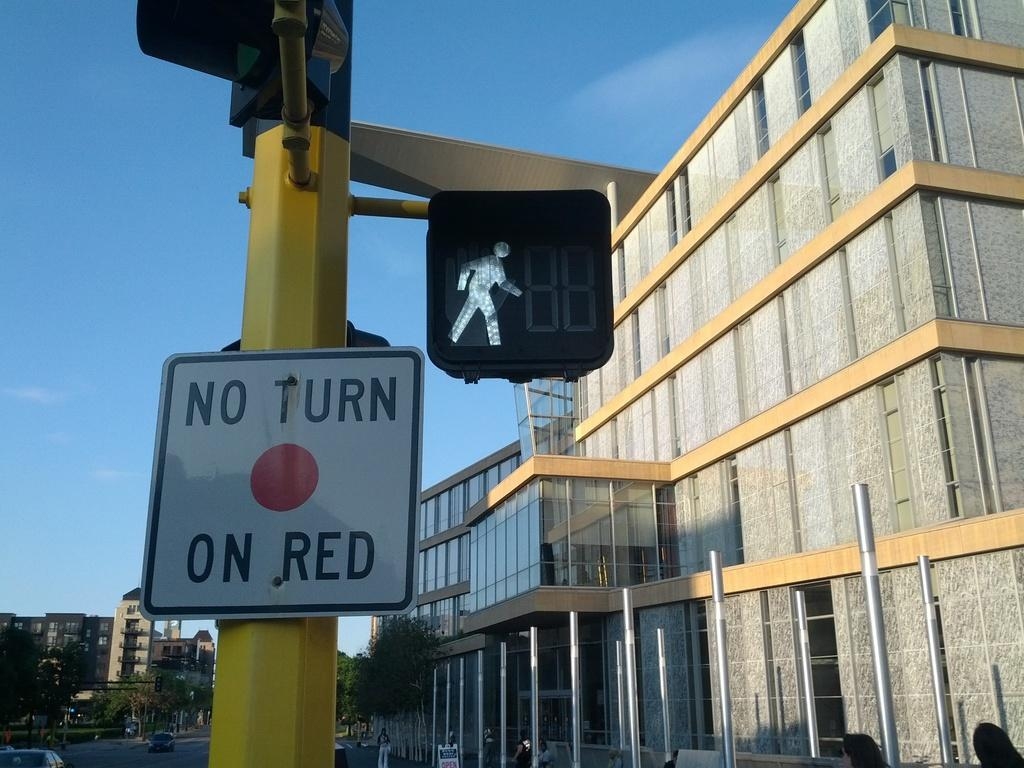<image>
Offer a succinct explanation of the picture presented. A pedestrian crossing light with a sign next to it that says 'no turn on red' 